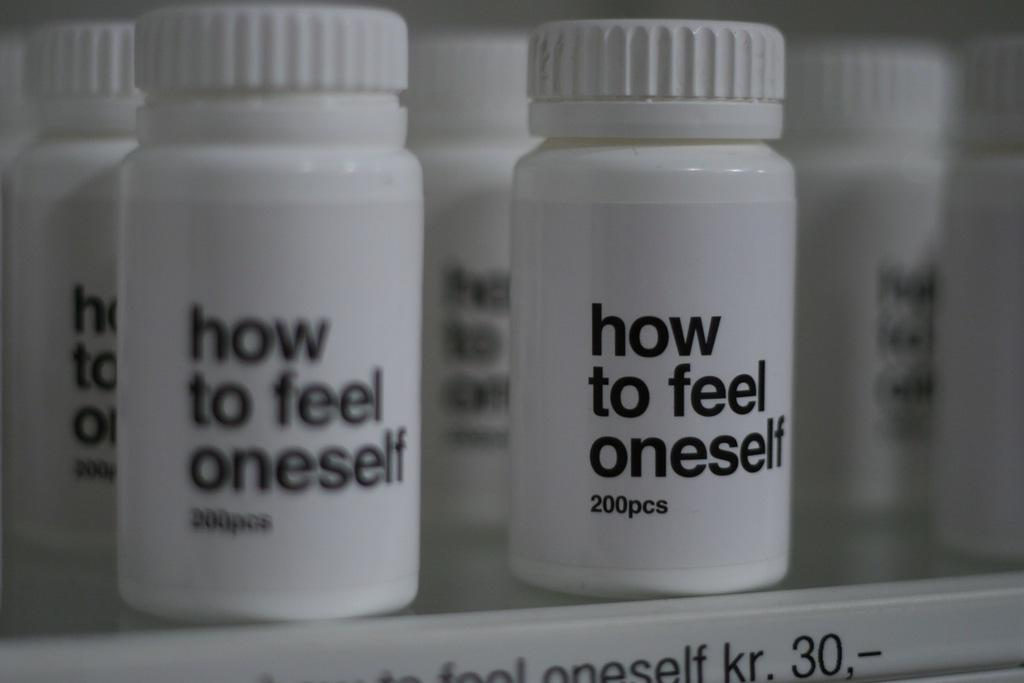<image>
Render a clear and concise summary of the photo. Pill bottles with the words "How to feel oneself" 200 pcs 